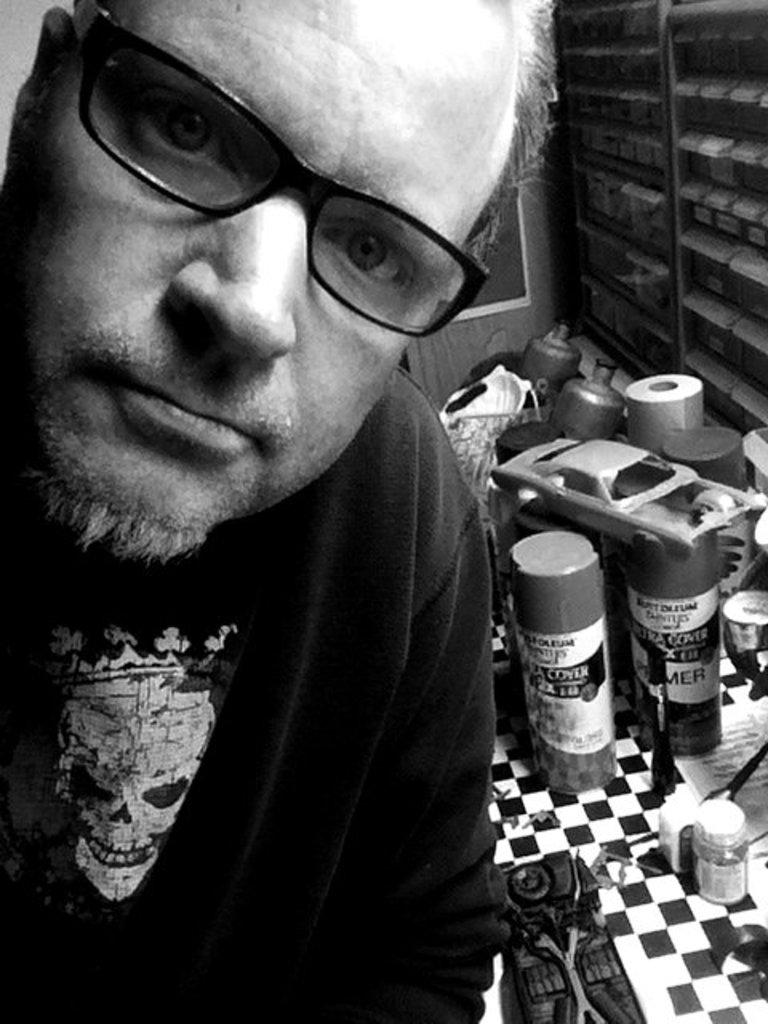What is located on the left side of the image? There is a man on the left side of the image. What can be observed about the man's appearance? The man is wearing spectacles. What objects are visible behind the man? There are bottles and other things visible behind the man. What is the color scheme of the image? The photograph is black and white. What type of fruit is being tested in the image? There is no fruit or testing activity present in the image. What time of day is depicted in the image? The image does not provide any information about the time of day, as it is black and white. 